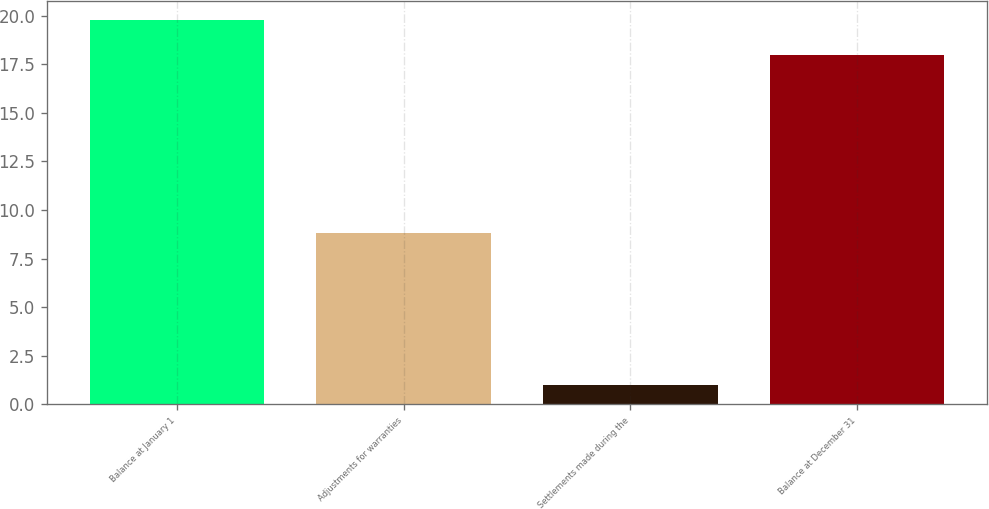Convert chart. <chart><loc_0><loc_0><loc_500><loc_500><bar_chart><fcel>Balance at January 1<fcel>Adjustments for warranties<fcel>Settlements made during the<fcel>Balance at December 31<nl><fcel>19.8<fcel>8.8<fcel>1<fcel>18<nl></chart> 